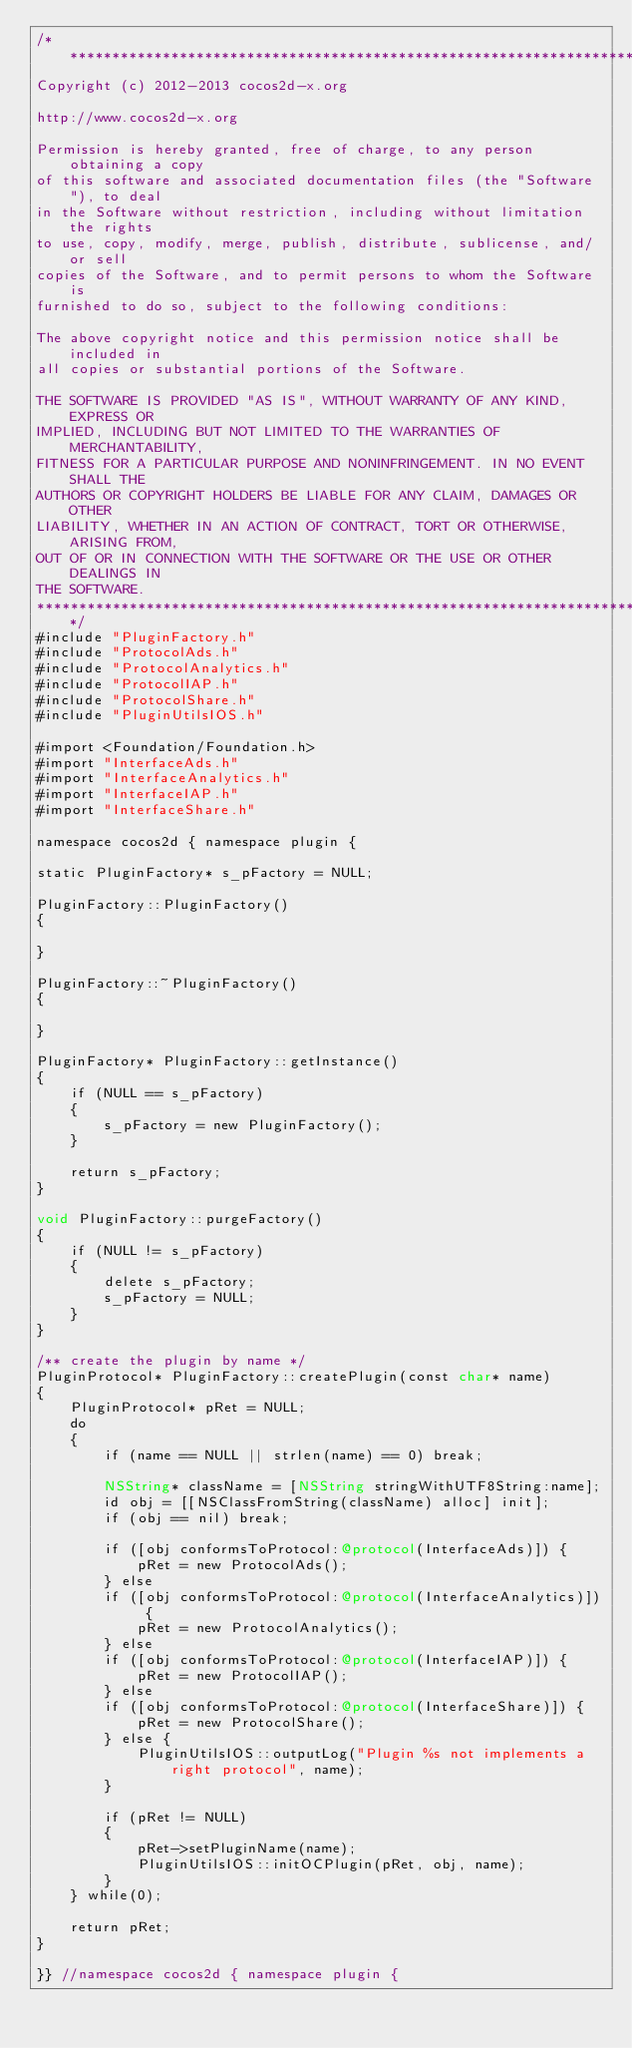Convert code to text. <code><loc_0><loc_0><loc_500><loc_500><_ObjectiveC_>/****************************************************************************
Copyright (c) 2012-2013 cocos2d-x.org

http://www.cocos2d-x.org

Permission is hereby granted, free of charge, to any person obtaining a copy
of this software and associated documentation files (the "Software"), to deal
in the Software without restriction, including without limitation the rights
to use, copy, modify, merge, publish, distribute, sublicense, and/or sell
copies of the Software, and to permit persons to whom the Software is
furnished to do so, subject to the following conditions:

The above copyright notice and this permission notice shall be included in
all copies or substantial portions of the Software.

THE SOFTWARE IS PROVIDED "AS IS", WITHOUT WARRANTY OF ANY KIND, EXPRESS OR
IMPLIED, INCLUDING BUT NOT LIMITED TO THE WARRANTIES OF MERCHANTABILITY,
FITNESS FOR A PARTICULAR PURPOSE AND NONINFRINGEMENT. IN NO EVENT SHALL THE
AUTHORS OR COPYRIGHT HOLDERS BE LIABLE FOR ANY CLAIM, DAMAGES OR OTHER
LIABILITY, WHETHER IN AN ACTION OF CONTRACT, TORT OR OTHERWISE, ARISING FROM,
OUT OF OR IN CONNECTION WITH THE SOFTWARE OR THE USE OR OTHER DEALINGS IN
THE SOFTWARE.
****************************************************************************/
#include "PluginFactory.h"
#include "ProtocolAds.h"
#include "ProtocolAnalytics.h"
#include "ProtocolIAP.h"
#include "ProtocolShare.h"
#include "PluginUtilsIOS.h"

#import <Foundation/Foundation.h>
#import "InterfaceAds.h"
#import "InterfaceAnalytics.h"
#import "InterfaceIAP.h"
#import "InterfaceShare.h"

namespace cocos2d { namespace plugin {

static PluginFactory* s_pFactory = NULL;

PluginFactory::PluginFactory()
{

}

PluginFactory::~PluginFactory()
{

}

PluginFactory* PluginFactory::getInstance()
{
	if (NULL == s_pFactory)
	{
		s_pFactory = new PluginFactory();
	}

	return s_pFactory;
}

void PluginFactory::purgeFactory()
{
	if (NULL != s_pFactory)
	{
		delete s_pFactory;
		s_pFactory = NULL;
	}
}

/** create the plugin by name */
PluginProtocol* PluginFactory::createPlugin(const char* name)
{
	PluginProtocol* pRet = NULL;
	do
	{
		if (name == NULL || strlen(name) == 0) break;

        NSString* className = [NSString stringWithUTF8String:name];
        id obj = [[NSClassFromString(className) alloc] init];
        if (obj == nil) break;

        if ([obj conformsToProtocol:@protocol(InterfaceAds)]) {
            pRet = new ProtocolAds();
        } else
        if ([obj conformsToProtocol:@protocol(InterfaceAnalytics)]) {
            pRet = new ProtocolAnalytics();
        } else
        if ([obj conformsToProtocol:@protocol(InterfaceIAP)]) {
            pRet = new ProtocolIAP();
        } else
        if ([obj conformsToProtocol:@protocol(InterfaceShare)]) {
            pRet = new ProtocolShare();
        } else {
            PluginUtilsIOS::outputLog("Plugin %s not implements a right protocol", name);
        }

		if (pRet != NULL)
		{
			pRet->setPluginName(name);
			PluginUtilsIOS::initOCPlugin(pRet, obj, name);
		}
	} while(0);

	return pRet;
}

}} //namespace cocos2d { namespace plugin {
</code> 